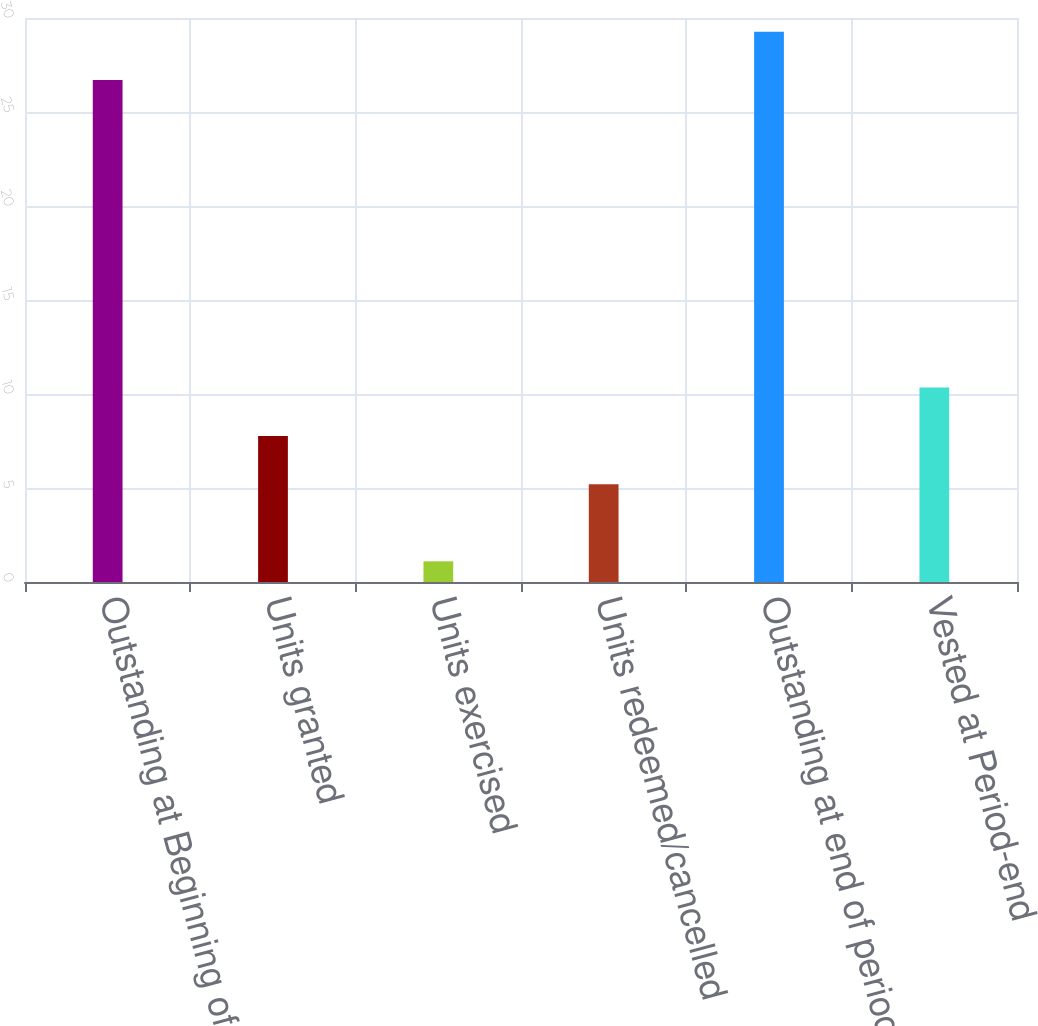<chart> <loc_0><loc_0><loc_500><loc_500><bar_chart><fcel>Outstanding at Beginning of<fcel>Units granted<fcel>Units exercised<fcel>Units redeemed/cancelled<fcel>Outstanding at end of period<fcel>Vested at Period-end<nl><fcel>26.7<fcel>7.77<fcel>1.1<fcel>5.2<fcel>29.27<fcel>10.34<nl></chart> 